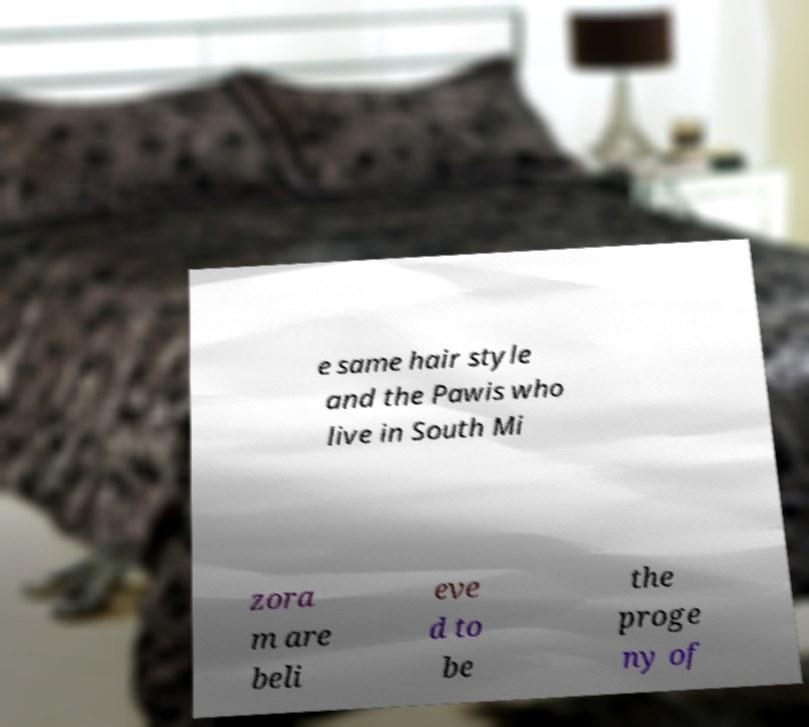Could you assist in decoding the text presented in this image and type it out clearly? e same hair style and the Pawis who live in South Mi zora m are beli eve d to be the proge ny of 